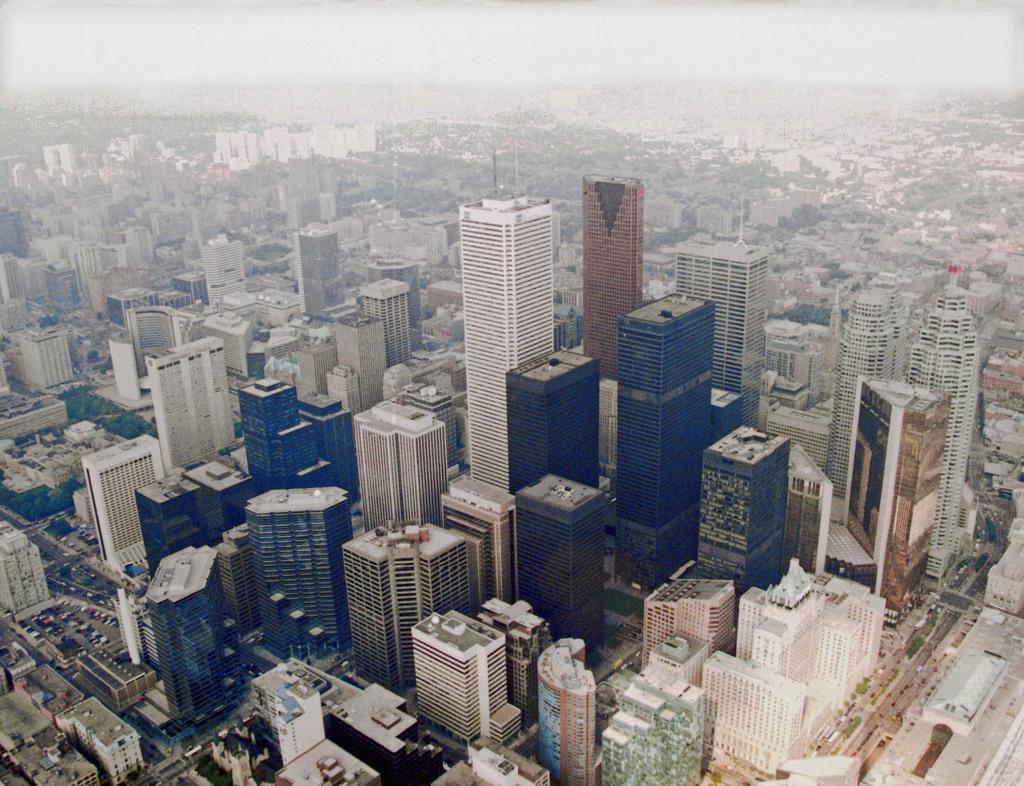Describe this image in one or two sentences. In this image we can see a group of buildings, vehicles, roads, trees are present. At the top of the image sky is there. 